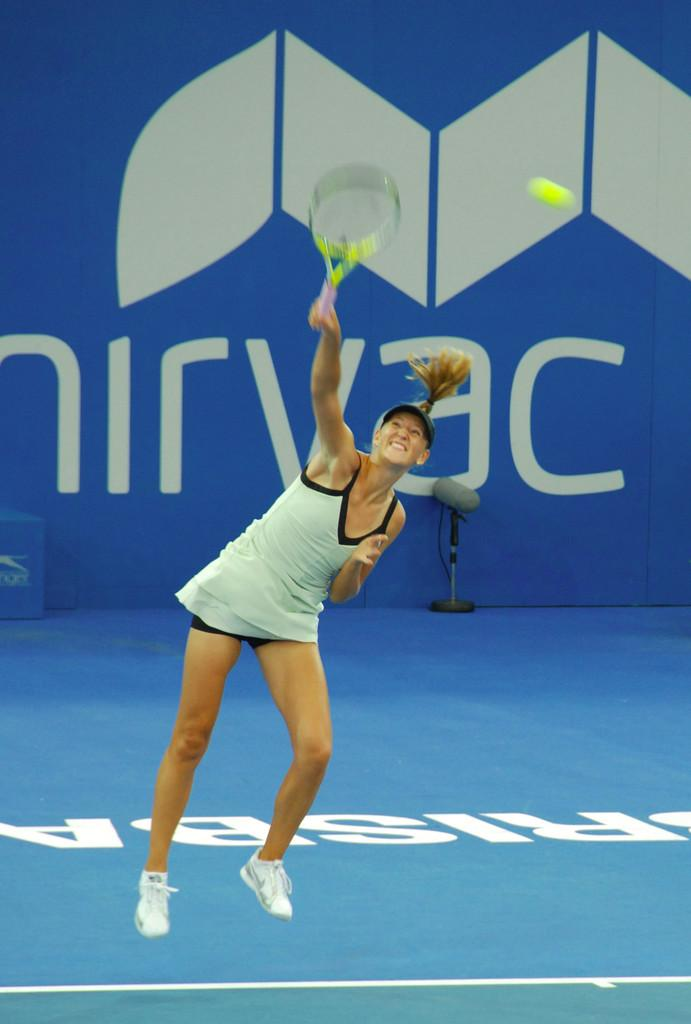Who is the main subject in the image? There is a woman in the image. What is the woman doing in the image? The woman is playing badminton. What can be seen in the background of the image? There is a board visible in the background of the image. How many parcels can be seen in the image? There are no parcels present in the image. What type of pen is the woman using to play badminton in the image? The woman is playing badminton with a badminton racket, not a pen, so there is no pen involved in the image. 